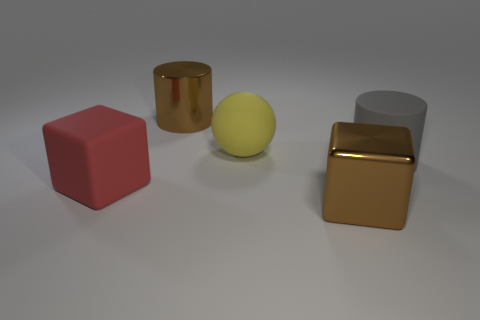Is there anything else that is the same color as the big shiny cylinder?
Provide a succinct answer. Yes. What shape is the large gray thing that is the same material as the yellow object?
Offer a terse response. Cylinder. Is the red object the same size as the brown cylinder?
Keep it short and to the point. Yes. Does the big brown thing that is behind the gray rubber object have the same material as the red block?
Ensure brevity in your answer.  No. Are there any other things that are made of the same material as the large sphere?
Provide a short and direct response. Yes. How many big yellow balls are to the right of the large brown thing behind the large brown metal object that is right of the large ball?
Offer a very short reply. 1. There is a large red matte thing to the left of the gray matte object; is its shape the same as the big yellow matte thing?
Your answer should be very brief. No. How many things are either rubber balls or big shiny things in front of the big shiny cylinder?
Offer a terse response. 2. Is the number of metallic things that are on the right side of the big rubber cylinder greater than the number of cyan rubber blocks?
Make the answer very short. No. Are there an equal number of large gray cylinders behind the metal cylinder and big gray objects in front of the big metal cube?
Your answer should be compact. Yes. 